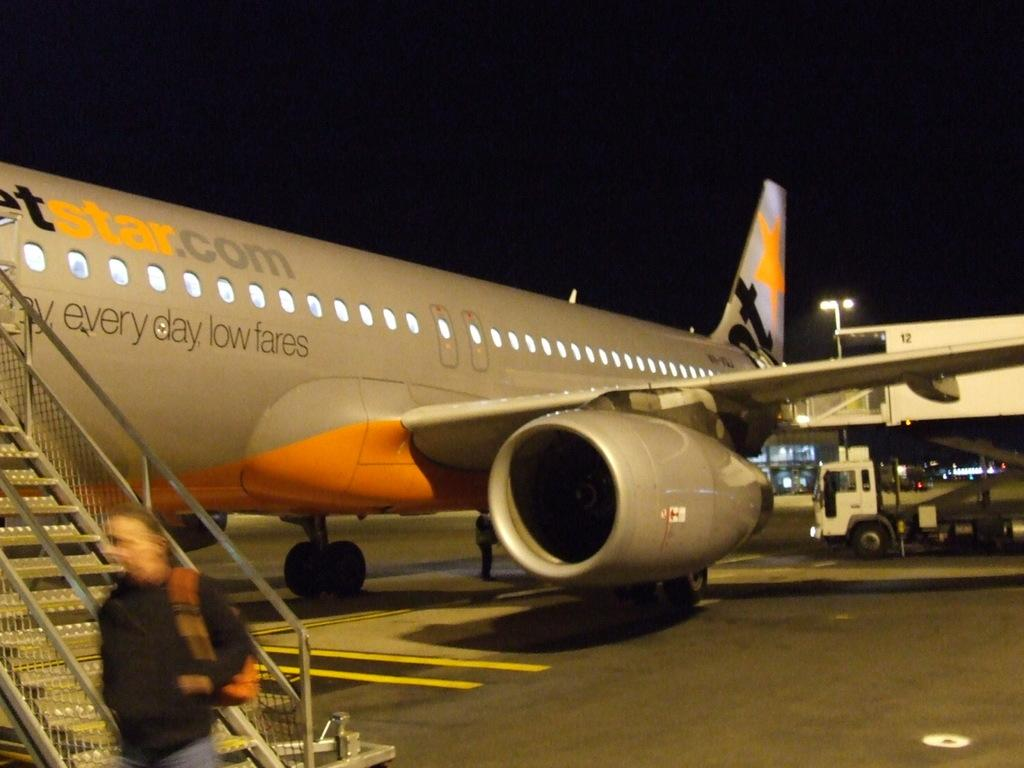<image>
Give a short and clear explanation of the subsequent image. A plane with an orange star on its tail advertises everyday low fares. 